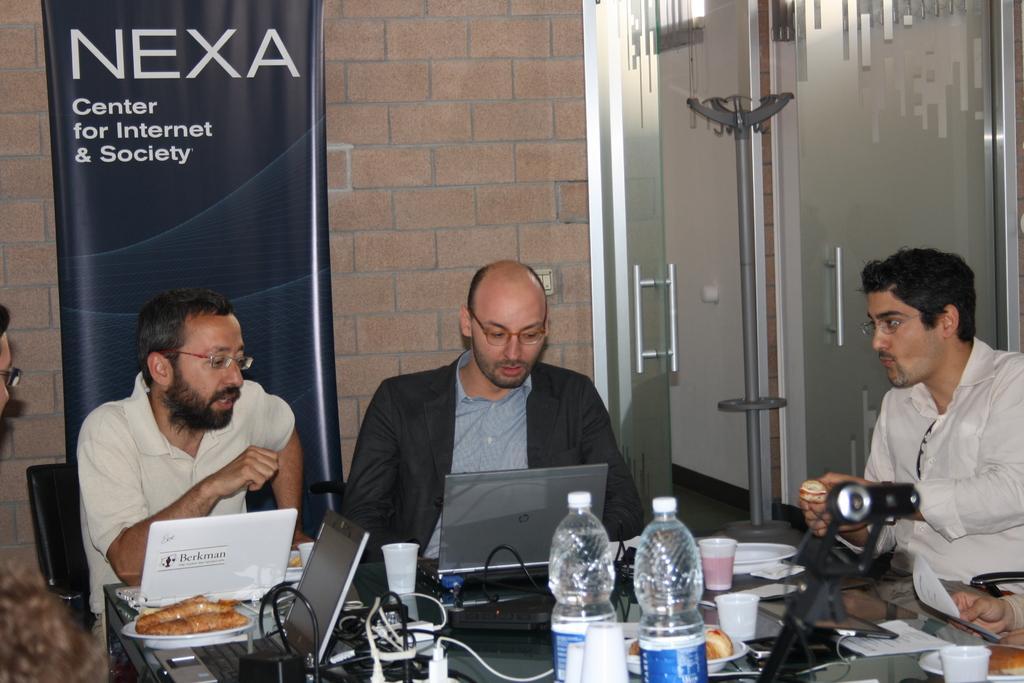Can you describe this image briefly? There are three members sitting in the chairs around the table on which some bottles, laptops, food items, cups and chargers were placed. All of them were spectacles. In the left side there is another man sitting. In the background there is a wall and a poster here. 